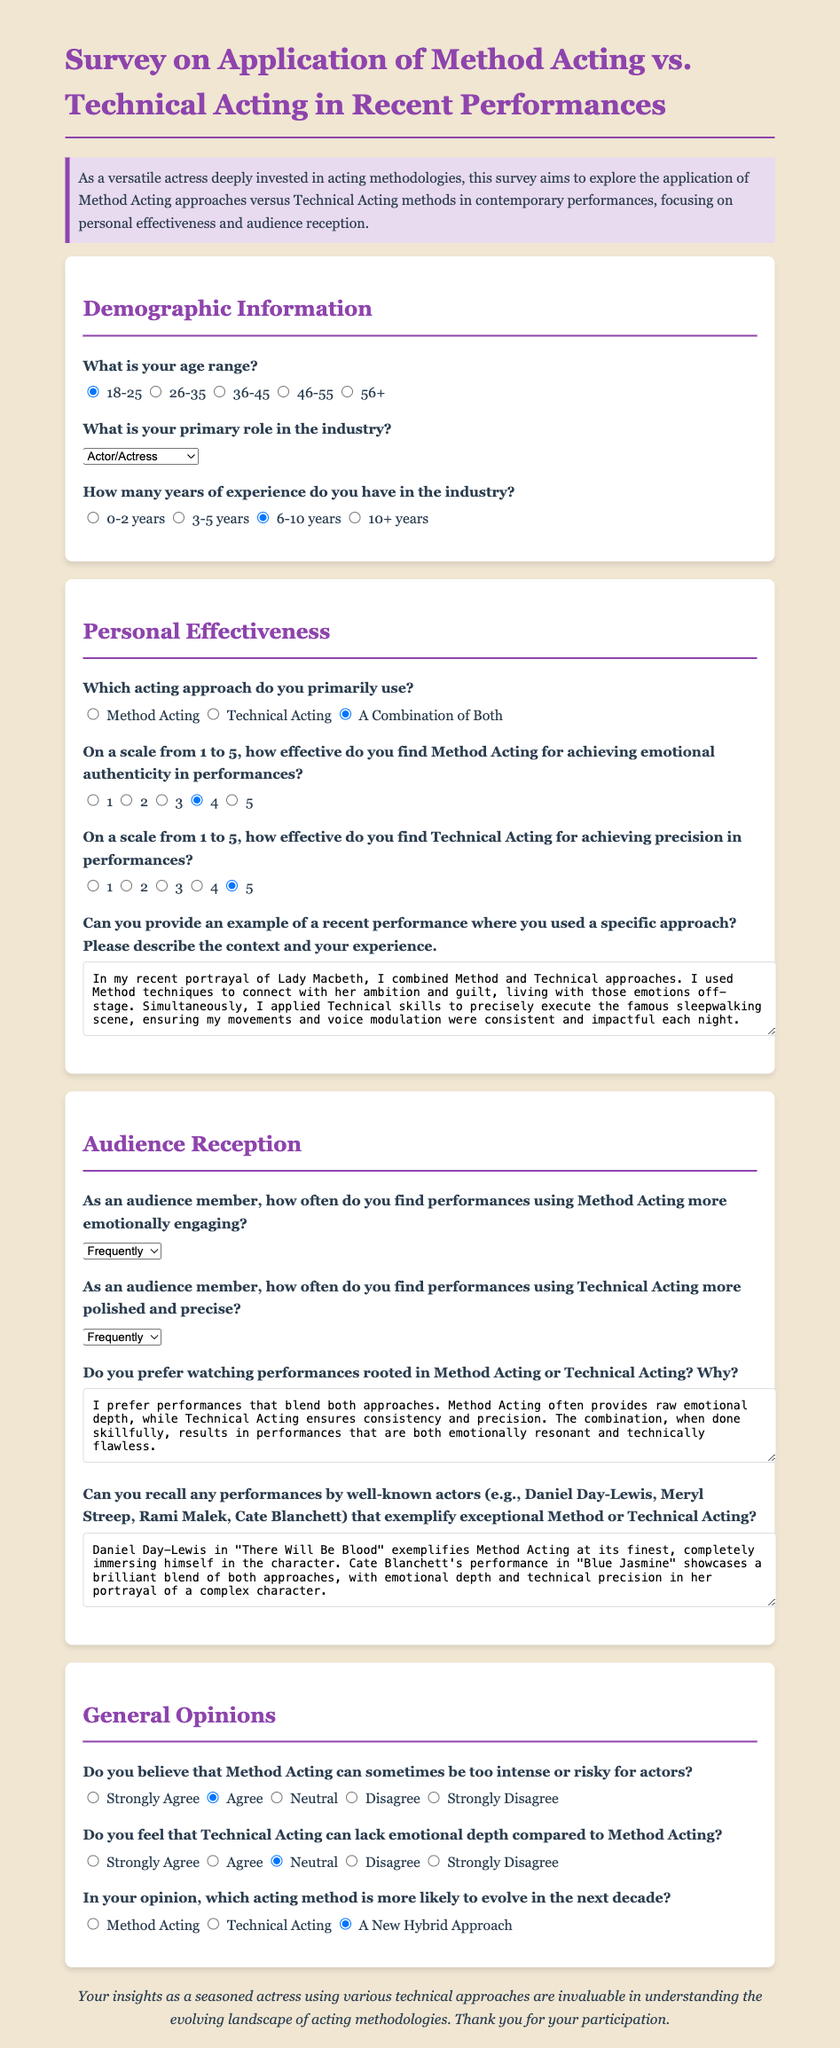What is your age range? The question prompts the respondent to select their age category, which ranges from 18-25 to 56+.
Answer: 18-25 What is your primary role in the industry? This question asks the respondent to identify their main occupation in the industry, with options including Actor, Director, etc.
Answer: Actor/Actress How many years of experience do you have in the industry? The question asks for the number of years the respondent has worked in the industry, with options from 0-2 years to 10+ years.
Answer: 6-10 years On a scale from 1 to 5, how effective do you find Method Acting for achieving emotional authenticity? This question requires a number response indicating the perceived effectiveness of Method Acting, with 1 being least effective and 5 being most effective.
Answer: 4 What is the frequency of finding performances using Method Acting more engaging? The question asks about the frequency of finding Method Acting performances emotionally engaging, with options like Always and Frequently.
Answer: Frequently What does the respondent prefer watching, Method Acting or Technical Acting? This question seeks to understand the respondent's preference regarding the acting approaches, leading to qualitative reasoning.
Answer: A Combination of Both What recent performance used a specific approach described in the answers? This question asks for an example of a recent performance where a specific acting approach was applied, based on the respondent's experience.
Answer: Lady Macbeth Do you believe that Method Acting can sometimes be too intense for actors? The question solicits an opinion regarding the risks associated with Method Acting, requiring a response in agreement or disagreement.
Answer: Agree Which acting method is likely to evolve in the next decade? This question asks the opinion about which acting method may see more change in the future, among the listed options.
Answer: A New Hybrid Approach 